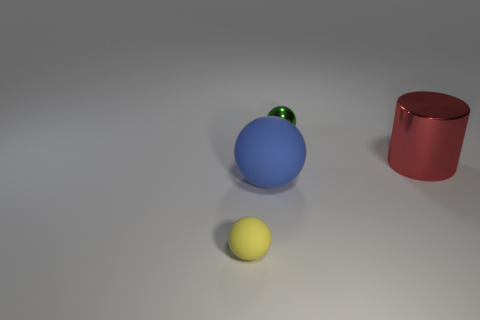What feelings or themes could this image represent? This image could evoke a sense of simplicity and calm due to the minimalistic composition of the objects and the soft lighting. The arrangement, with one object slightly elevated and in a different color, might suggest themes of individuality or standing out. 